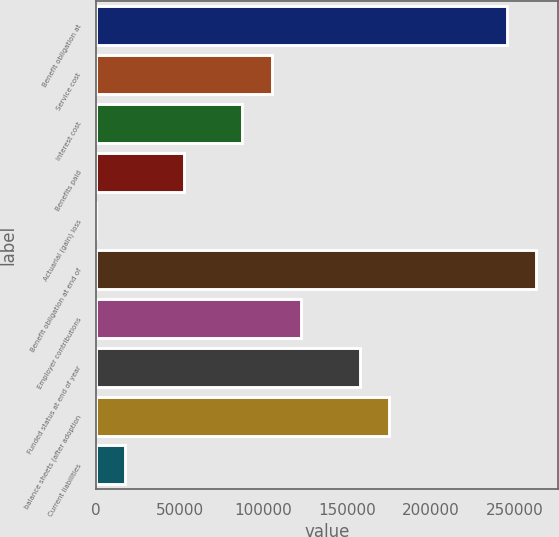Convert chart to OTSL. <chart><loc_0><loc_0><loc_500><loc_500><bar_chart><fcel>Benefit obligation at<fcel>Service cost<fcel>Interest cost<fcel>Benefits paid<fcel>Actuarial (gain) loss<fcel>Benefit obligation at end of<fcel>Employer contributions<fcel>Funded status at end of year<fcel>balance sheets (after adoption<fcel>Current liabilities<nl><fcel>245208<fcel>105100<fcel>87586<fcel>52558.8<fcel>18<fcel>262722<fcel>122613<fcel>157640<fcel>175154<fcel>17531.6<nl></chart> 